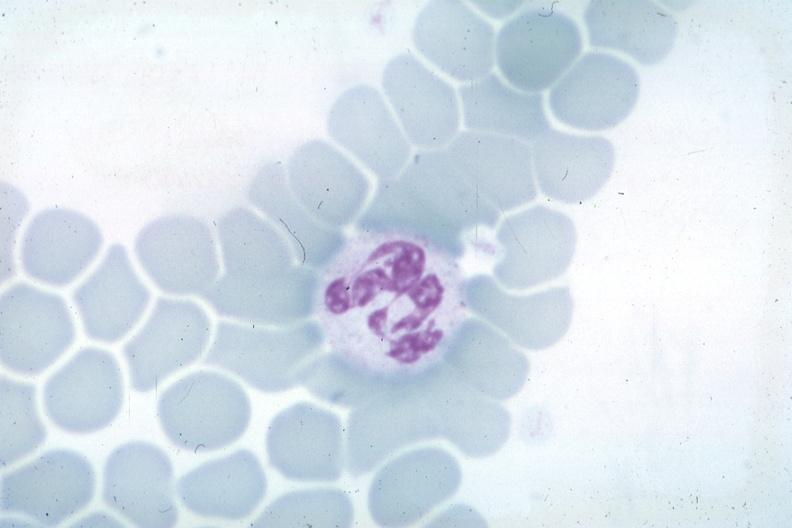what is present?
Answer the question using a single word or phrase. Hypersegmented neutrophil 